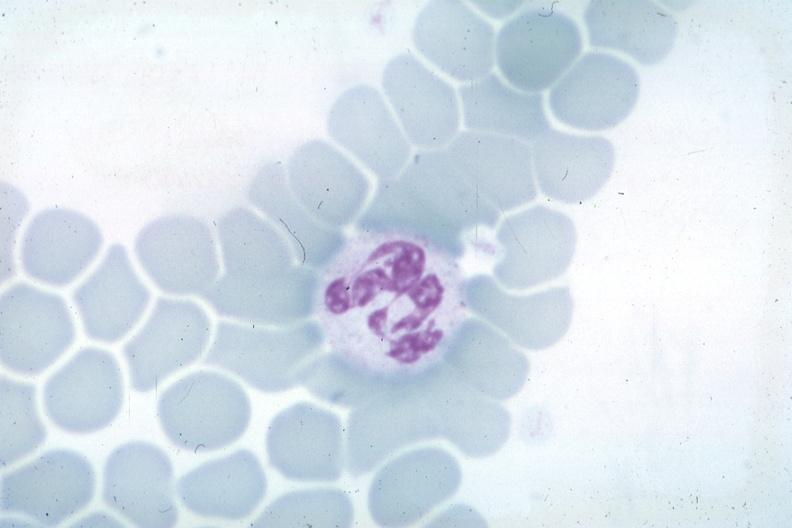what is present?
Answer the question using a single word or phrase. Hypersegmented neutrophil 